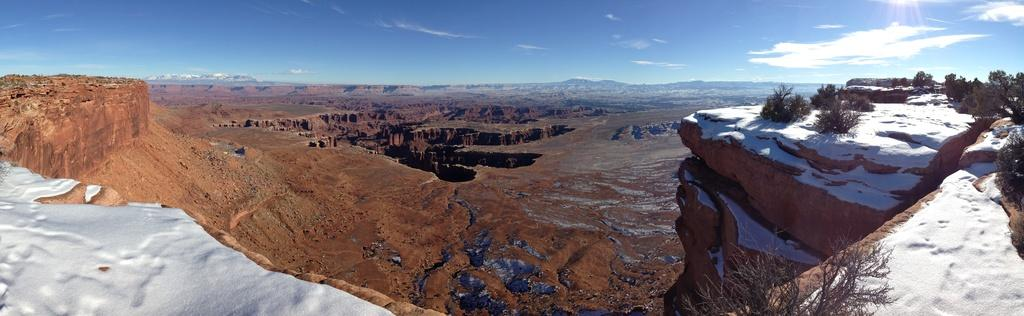What type of terrain is visible in the image? There are hills in the image. What can be seen on the right side of the image? There are trees on the right side of the image. What is covering the ground in the image? The ground is covered with snow. Is there snow visible on both sides of the image? Yes, there is snow on the left side of the image as well. What is visible in the background of the image? The sky is visible in the background of the image. What can be seen in the sky? There are clouds in the sky. What type of machine is being used to create the stars in the image? There are no stars or machines present in the image; it features hills, trees, snow, and clouds. 